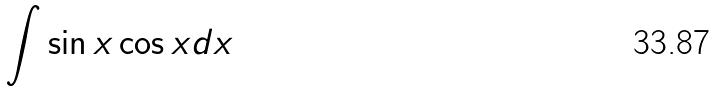<formula> <loc_0><loc_0><loc_500><loc_500>\int \sin x \cos x d x</formula> 